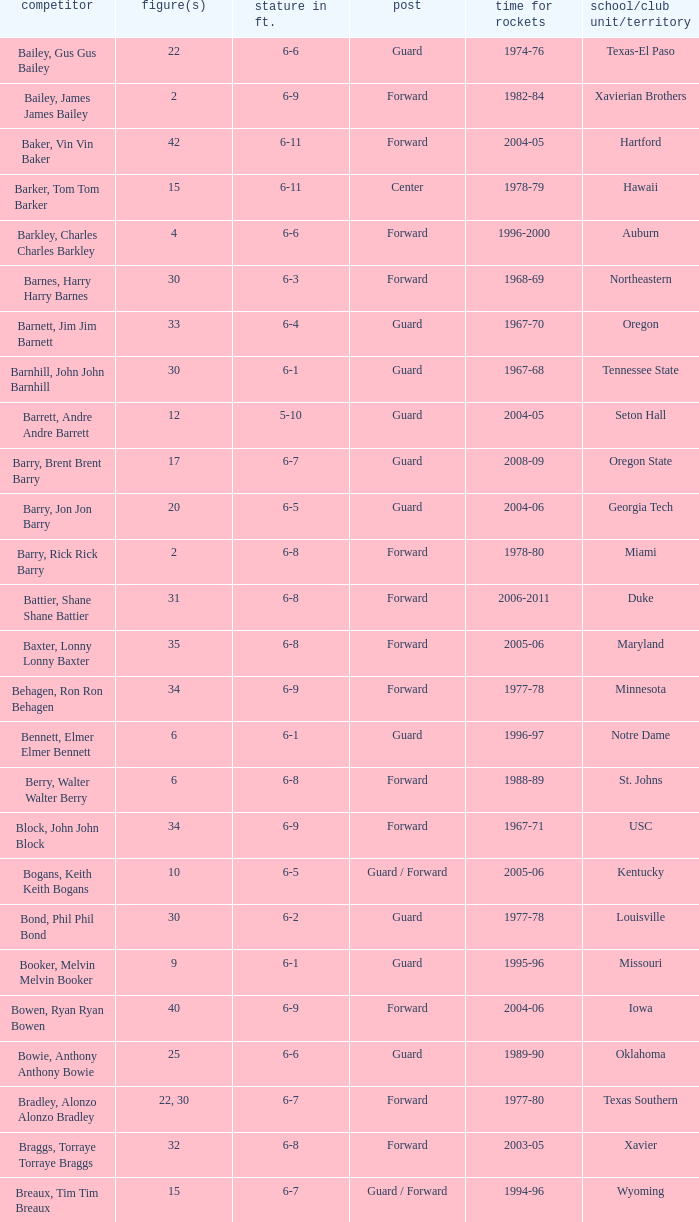What years did the player from LaSalle play for the Rockets? 1982-83. 